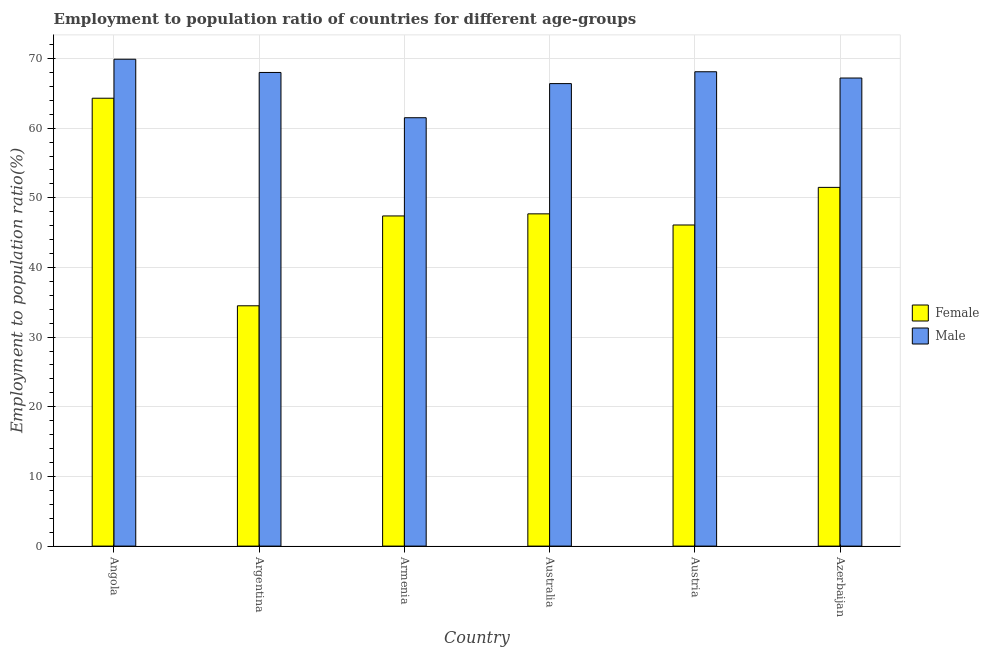How many different coloured bars are there?
Your answer should be compact. 2. Are the number of bars per tick equal to the number of legend labels?
Offer a terse response. Yes. Are the number of bars on each tick of the X-axis equal?
Ensure brevity in your answer.  Yes. How many bars are there on the 2nd tick from the left?
Offer a terse response. 2. How many bars are there on the 2nd tick from the right?
Offer a terse response. 2. What is the label of the 3rd group of bars from the left?
Offer a terse response. Armenia. What is the employment to population ratio(male) in Austria?
Provide a short and direct response. 68.1. Across all countries, what is the maximum employment to population ratio(female)?
Your response must be concise. 64.3. Across all countries, what is the minimum employment to population ratio(female)?
Offer a very short reply. 34.5. In which country was the employment to population ratio(female) maximum?
Offer a very short reply. Angola. In which country was the employment to population ratio(male) minimum?
Your answer should be compact. Armenia. What is the total employment to population ratio(female) in the graph?
Keep it short and to the point. 291.5. What is the difference between the employment to population ratio(female) in Armenia and that in Australia?
Offer a very short reply. -0.3. What is the difference between the employment to population ratio(male) in Azerbaijan and the employment to population ratio(female) in Austria?
Your response must be concise. 21.1. What is the average employment to population ratio(male) per country?
Your answer should be very brief. 66.85. What is the difference between the employment to population ratio(female) and employment to population ratio(male) in Austria?
Give a very brief answer. -22. What is the ratio of the employment to population ratio(female) in Angola to that in Australia?
Provide a short and direct response. 1.35. Is the employment to population ratio(male) in Argentina less than that in Armenia?
Keep it short and to the point. No. What is the difference between the highest and the second highest employment to population ratio(male)?
Make the answer very short. 1.8. What is the difference between the highest and the lowest employment to population ratio(female)?
Provide a short and direct response. 29.8. In how many countries, is the employment to population ratio(female) greater than the average employment to population ratio(female) taken over all countries?
Ensure brevity in your answer.  2. Is the sum of the employment to population ratio(male) in Argentina and Azerbaijan greater than the maximum employment to population ratio(female) across all countries?
Offer a terse response. Yes. Are all the bars in the graph horizontal?
Keep it short and to the point. No. What is the difference between two consecutive major ticks on the Y-axis?
Make the answer very short. 10. Are the values on the major ticks of Y-axis written in scientific E-notation?
Ensure brevity in your answer.  No. Does the graph contain grids?
Keep it short and to the point. Yes. How many legend labels are there?
Offer a terse response. 2. How are the legend labels stacked?
Provide a succinct answer. Vertical. What is the title of the graph?
Provide a succinct answer. Employment to population ratio of countries for different age-groups. What is the label or title of the X-axis?
Offer a terse response. Country. What is the label or title of the Y-axis?
Offer a very short reply. Employment to population ratio(%). What is the Employment to population ratio(%) in Female in Angola?
Give a very brief answer. 64.3. What is the Employment to population ratio(%) in Male in Angola?
Offer a terse response. 69.9. What is the Employment to population ratio(%) in Female in Argentina?
Offer a very short reply. 34.5. What is the Employment to population ratio(%) in Male in Argentina?
Provide a short and direct response. 68. What is the Employment to population ratio(%) in Female in Armenia?
Provide a succinct answer. 47.4. What is the Employment to population ratio(%) in Male in Armenia?
Provide a succinct answer. 61.5. What is the Employment to population ratio(%) of Female in Australia?
Your answer should be compact. 47.7. What is the Employment to population ratio(%) of Male in Australia?
Your answer should be compact. 66.4. What is the Employment to population ratio(%) of Female in Austria?
Provide a succinct answer. 46.1. What is the Employment to population ratio(%) of Male in Austria?
Offer a terse response. 68.1. What is the Employment to population ratio(%) of Female in Azerbaijan?
Your answer should be very brief. 51.5. What is the Employment to population ratio(%) of Male in Azerbaijan?
Make the answer very short. 67.2. Across all countries, what is the maximum Employment to population ratio(%) in Female?
Provide a short and direct response. 64.3. Across all countries, what is the maximum Employment to population ratio(%) of Male?
Your answer should be very brief. 69.9. Across all countries, what is the minimum Employment to population ratio(%) of Female?
Offer a very short reply. 34.5. Across all countries, what is the minimum Employment to population ratio(%) in Male?
Your answer should be very brief. 61.5. What is the total Employment to population ratio(%) of Female in the graph?
Provide a succinct answer. 291.5. What is the total Employment to population ratio(%) in Male in the graph?
Offer a terse response. 401.1. What is the difference between the Employment to population ratio(%) in Female in Angola and that in Argentina?
Make the answer very short. 29.8. What is the difference between the Employment to population ratio(%) in Male in Angola and that in Argentina?
Ensure brevity in your answer.  1.9. What is the difference between the Employment to population ratio(%) of Male in Angola and that in Armenia?
Make the answer very short. 8.4. What is the difference between the Employment to population ratio(%) in Female in Angola and that in Australia?
Give a very brief answer. 16.6. What is the difference between the Employment to population ratio(%) in Female in Angola and that in Austria?
Keep it short and to the point. 18.2. What is the difference between the Employment to population ratio(%) of Male in Angola and that in Austria?
Provide a succinct answer. 1.8. What is the difference between the Employment to population ratio(%) of Male in Angola and that in Azerbaijan?
Your answer should be compact. 2.7. What is the difference between the Employment to population ratio(%) in Female in Argentina and that in Australia?
Your answer should be very brief. -13.2. What is the difference between the Employment to population ratio(%) of Female in Argentina and that in Austria?
Keep it short and to the point. -11.6. What is the difference between the Employment to population ratio(%) in Male in Argentina and that in Austria?
Provide a short and direct response. -0.1. What is the difference between the Employment to population ratio(%) of Female in Armenia and that in Australia?
Offer a terse response. -0.3. What is the difference between the Employment to population ratio(%) of Male in Armenia and that in Australia?
Your answer should be very brief. -4.9. What is the difference between the Employment to population ratio(%) in Female in Armenia and that in Austria?
Provide a succinct answer. 1.3. What is the difference between the Employment to population ratio(%) in Male in Armenia and that in Austria?
Your answer should be very brief. -6.6. What is the difference between the Employment to population ratio(%) of Female in Armenia and that in Azerbaijan?
Your answer should be compact. -4.1. What is the difference between the Employment to population ratio(%) of Male in Australia and that in Austria?
Your answer should be compact. -1.7. What is the difference between the Employment to population ratio(%) in Male in Australia and that in Azerbaijan?
Provide a succinct answer. -0.8. What is the difference between the Employment to population ratio(%) in Female in Austria and that in Azerbaijan?
Make the answer very short. -5.4. What is the difference between the Employment to population ratio(%) of Male in Austria and that in Azerbaijan?
Your answer should be very brief. 0.9. What is the difference between the Employment to population ratio(%) of Female in Angola and the Employment to population ratio(%) of Male in Argentina?
Your answer should be very brief. -3.7. What is the difference between the Employment to population ratio(%) of Female in Angola and the Employment to population ratio(%) of Male in Armenia?
Offer a terse response. 2.8. What is the difference between the Employment to population ratio(%) of Female in Angola and the Employment to population ratio(%) of Male in Austria?
Your response must be concise. -3.8. What is the difference between the Employment to population ratio(%) in Female in Angola and the Employment to population ratio(%) in Male in Azerbaijan?
Give a very brief answer. -2.9. What is the difference between the Employment to population ratio(%) of Female in Argentina and the Employment to population ratio(%) of Male in Australia?
Your answer should be very brief. -31.9. What is the difference between the Employment to population ratio(%) of Female in Argentina and the Employment to population ratio(%) of Male in Austria?
Give a very brief answer. -33.6. What is the difference between the Employment to population ratio(%) in Female in Argentina and the Employment to population ratio(%) in Male in Azerbaijan?
Your answer should be very brief. -32.7. What is the difference between the Employment to population ratio(%) in Female in Armenia and the Employment to population ratio(%) in Male in Australia?
Ensure brevity in your answer.  -19. What is the difference between the Employment to population ratio(%) in Female in Armenia and the Employment to population ratio(%) in Male in Austria?
Your response must be concise. -20.7. What is the difference between the Employment to population ratio(%) of Female in Armenia and the Employment to population ratio(%) of Male in Azerbaijan?
Offer a terse response. -19.8. What is the difference between the Employment to population ratio(%) of Female in Australia and the Employment to population ratio(%) of Male in Austria?
Your answer should be very brief. -20.4. What is the difference between the Employment to population ratio(%) of Female in Australia and the Employment to population ratio(%) of Male in Azerbaijan?
Provide a short and direct response. -19.5. What is the difference between the Employment to population ratio(%) of Female in Austria and the Employment to population ratio(%) of Male in Azerbaijan?
Your answer should be compact. -21.1. What is the average Employment to population ratio(%) in Female per country?
Ensure brevity in your answer.  48.58. What is the average Employment to population ratio(%) in Male per country?
Offer a terse response. 66.85. What is the difference between the Employment to population ratio(%) of Female and Employment to population ratio(%) of Male in Argentina?
Keep it short and to the point. -33.5. What is the difference between the Employment to population ratio(%) in Female and Employment to population ratio(%) in Male in Armenia?
Ensure brevity in your answer.  -14.1. What is the difference between the Employment to population ratio(%) of Female and Employment to population ratio(%) of Male in Australia?
Your answer should be very brief. -18.7. What is the difference between the Employment to population ratio(%) in Female and Employment to population ratio(%) in Male in Austria?
Provide a short and direct response. -22. What is the difference between the Employment to population ratio(%) in Female and Employment to population ratio(%) in Male in Azerbaijan?
Your answer should be very brief. -15.7. What is the ratio of the Employment to population ratio(%) in Female in Angola to that in Argentina?
Ensure brevity in your answer.  1.86. What is the ratio of the Employment to population ratio(%) in Male in Angola to that in Argentina?
Provide a succinct answer. 1.03. What is the ratio of the Employment to population ratio(%) in Female in Angola to that in Armenia?
Offer a very short reply. 1.36. What is the ratio of the Employment to population ratio(%) in Male in Angola to that in Armenia?
Your response must be concise. 1.14. What is the ratio of the Employment to population ratio(%) in Female in Angola to that in Australia?
Offer a terse response. 1.35. What is the ratio of the Employment to population ratio(%) in Male in Angola to that in Australia?
Your answer should be very brief. 1.05. What is the ratio of the Employment to population ratio(%) of Female in Angola to that in Austria?
Give a very brief answer. 1.39. What is the ratio of the Employment to population ratio(%) of Male in Angola to that in Austria?
Offer a terse response. 1.03. What is the ratio of the Employment to population ratio(%) of Female in Angola to that in Azerbaijan?
Offer a very short reply. 1.25. What is the ratio of the Employment to population ratio(%) in Male in Angola to that in Azerbaijan?
Offer a terse response. 1.04. What is the ratio of the Employment to population ratio(%) in Female in Argentina to that in Armenia?
Your answer should be compact. 0.73. What is the ratio of the Employment to population ratio(%) of Male in Argentina to that in Armenia?
Your response must be concise. 1.11. What is the ratio of the Employment to population ratio(%) of Female in Argentina to that in Australia?
Your response must be concise. 0.72. What is the ratio of the Employment to population ratio(%) of Male in Argentina to that in Australia?
Provide a short and direct response. 1.02. What is the ratio of the Employment to population ratio(%) of Female in Argentina to that in Austria?
Your answer should be very brief. 0.75. What is the ratio of the Employment to population ratio(%) of Female in Argentina to that in Azerbaijan?
Offer a very short reply. 0.67. What is the ratio of the Employment to population ratio(%) of Male in Argentina to that in Azerbaijan?
Keep it short and to the point. 1.01. What is the ratio of the Employment to population ratio(%) in Female in Armenia to that in Australia?
Ensure brevity in your answer.  0.99. What is the ratio of the Employment to population ratio(%) of Male in Armenia to that in Australia?
Provide a short and direct response. 0.93. What is the ratio of the Employment to population ratio(%) of Female in Armenia to that in Austria?
Your response must be concise. 1.03. What is the ratio of the Employment to population ratio(%) of Male in Armenia to that in Austria?
Keep it short and to the point. 0.9. What is the ratio of the Employment to population ratio(%) of Female in Armenia to that in Azerbaijan?
Your answer should be very brief. 0.92. What is the ratio of the Employment to population ratio(%) in Male in Armenia to that in Azerbaijan?
Provide a succinct answer. 0.92. What is the ratio of the Employment to population ratio(%) in Female in Australia to that in Austria?
Provide a short and direct response. 1.03. What is the ratio of the Employment to population ratio(%) of Male in Australia to that in Austria?
Your answer should be very brief. 0.97. What is the ratio of the Employment to population ratio(%) in Female in Australia to that in Azerbaijan?
Your answer should be compact. 0.93. What is the ratio of the Employment to population ratio(%) in Female in Austria to that in Azerbaijan?
Your answer should be very brief. 0.9. What is the ratio of the Employment to population ratio(%) of Male in Austria to that in Azerbaijan?
Provide a succinct answer. 1.01. What is the difference between the highest and the second highest Employment to population ratio(%) in Male?
Provide a succinct answer. 1.8. What is the difference between the highest and the lowest Employment to population ratio(%) of Female?
Provide a succinct answer. 29.8. 